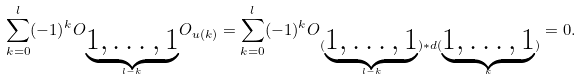Convert formula to latex. <formula><loc_0><loc_0><loc_500><loc_500>\sum _ { k = 0 } ^ { l } ( - 1 ) ^ { k } O _ { \underbrace { 1 , \dots , 1 } _ { l - k } } O _ { u ( k ) } = \sum _ { k = 0 } ^ { l } ( - 1 ) ^ { k } O _ { ( \underbrace { 1 , \dots , 1 } _ { l - k } ) * d ( \underbrace { 1 , \dots , 1 } _ { k } ) } = 0 .</formula> 